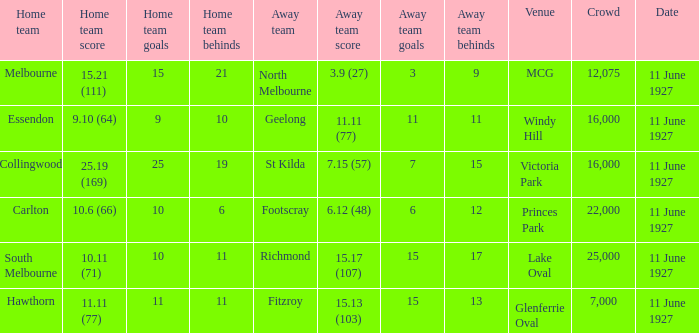How many individuals are in the combined crowds at glenferrie oval? 7000.0. 